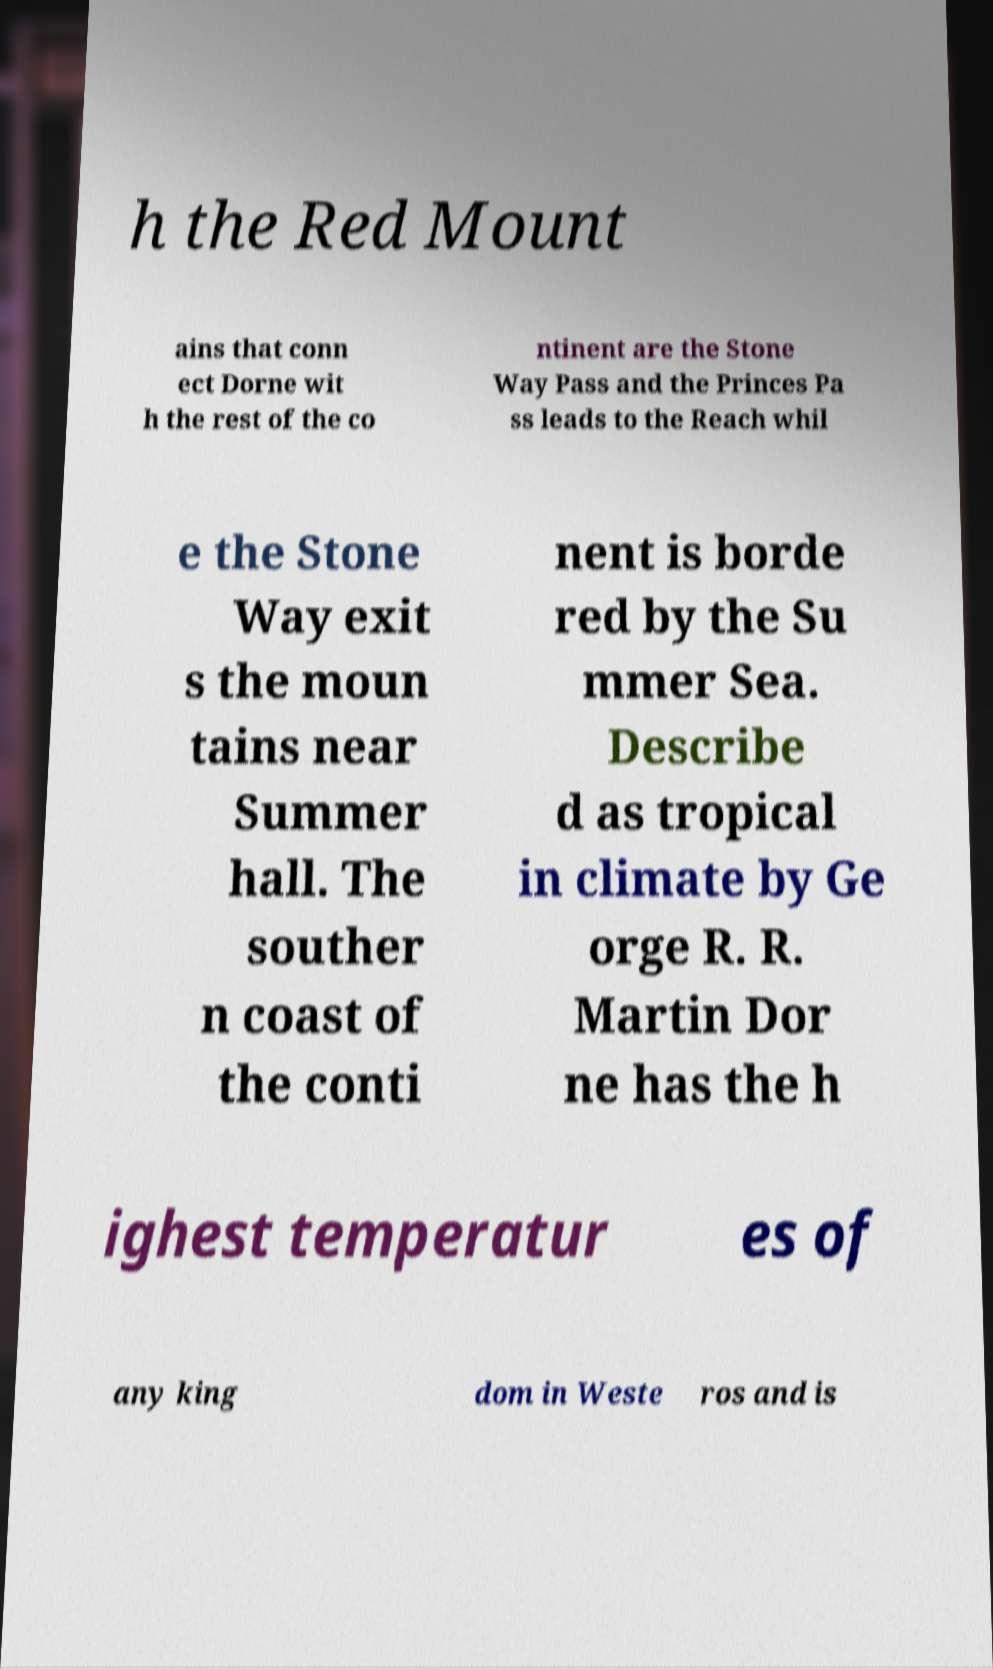Could you assist in decoding the text presented in this image and type it out clearly? h the Red Mount ains that conn ect Dorne wit h the rest of the co ntinent are the Stone Way Pass and the Princes Pa ss leads to the Reach whil e the Stone Way exit s the moun tains near Summer hall. The souther n coast of the conti nent is borde red by the Su mmer Sea. Describe d as tropical in climate by Ge orge R. R. Martin Dor ne has the h ighest temperatur es of any king dom in Weste ros and is 